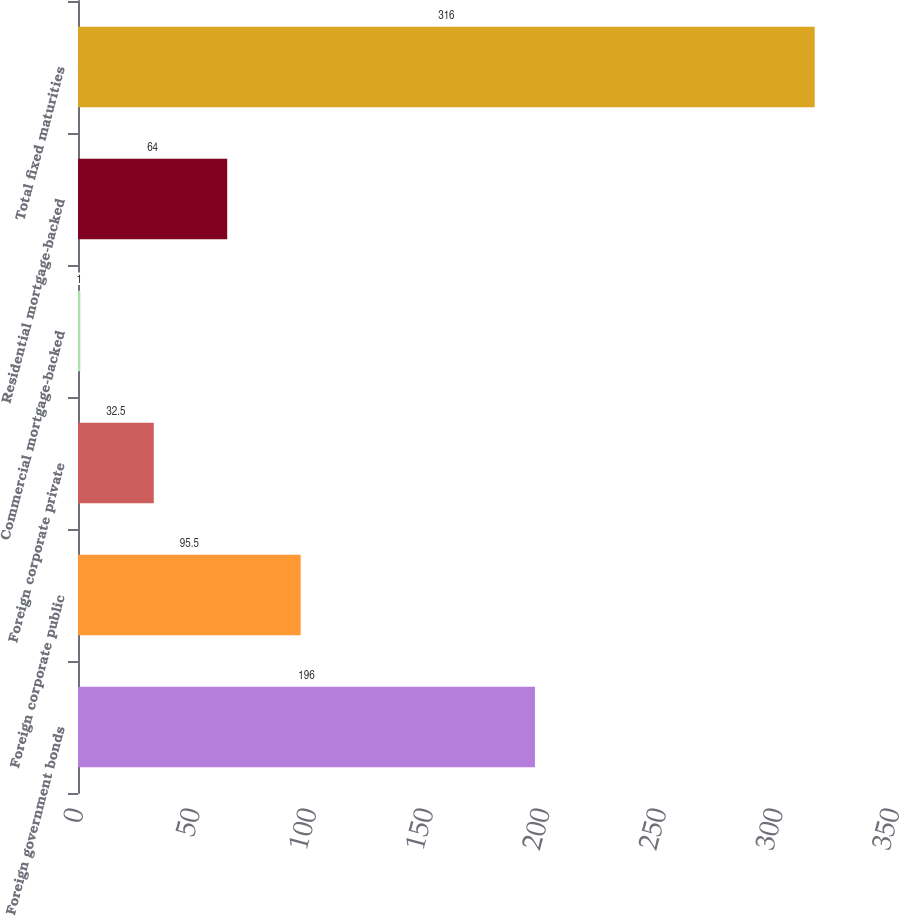Convert chart to OTSL. <chart><loc_0><loc_0><loc_500><loc_500><bar_chart><fcel>Foreign government bonds<fcel>Foreign corporate public<fcel>Foreign corporate private<fcel>Commercial mortgage-backed<fcel>Residential mortgage-backed<fcel>Total fixed maturities<nl><fcel>196<fcel>95.5<fcel>32.5<fcel>1<fcel>64<fcel>316<nl></chart> 